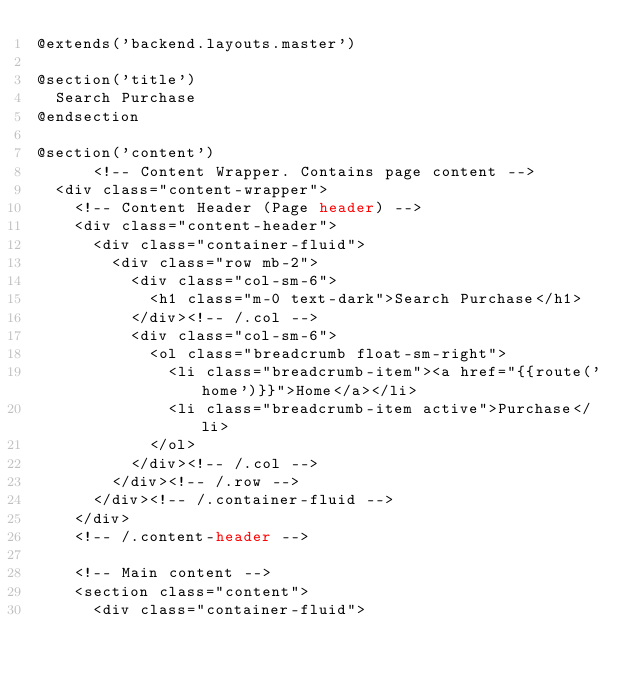Convert code to text. <code><loc_0><loc_0><loc_500><loc_500><_PHP_>@extends('backend.layouts.master')

@section('title')
  Search Purchase
@endsection

@section('content')
      <!-- Content Wrapper. Contains page content -->
  <div class="content-wrapper">
    <!-- Content Header (Page header) -->
    <div class="content-header">
      <div class="container-fluid">
        <div class="row mb-2">
          <div class="col-sm-6">
            <h1 class="m-0 text-dark">Search Purchase</h1>
          </div><!-- /.col -->
          <div class="col-sm-6">
            <ol class="breadcrumb float-sm-right">
              <li class="breadcrumb-item"><a href="{{route('home')}}">Home</a></li>
              <li class="breadcrumb-item active">Purchase</li>
            </ol>
          </div><!-- /.col -->
        </div><!-- /.row -->
      </div><!-- /.container-fluid -->
    </div>
    <!-- /.content-header -->

    <!-- Main content -->
    <section class="content">
      <div class="container-fluid">
       </code> 